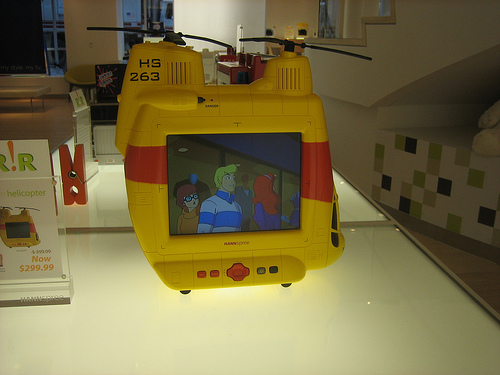<image>
Is the window on the tv? No. The window is not positioned on the tv. They may be near each other, but the window is not supported by or resting on top of the tv. 